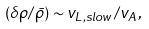<formula> <loc_0><loc_0><loc_500><loc_500>( \delta \rho / \bar { \rho } ) \sim v _ { L , s l o w } / v _ { A } ,</formula> 